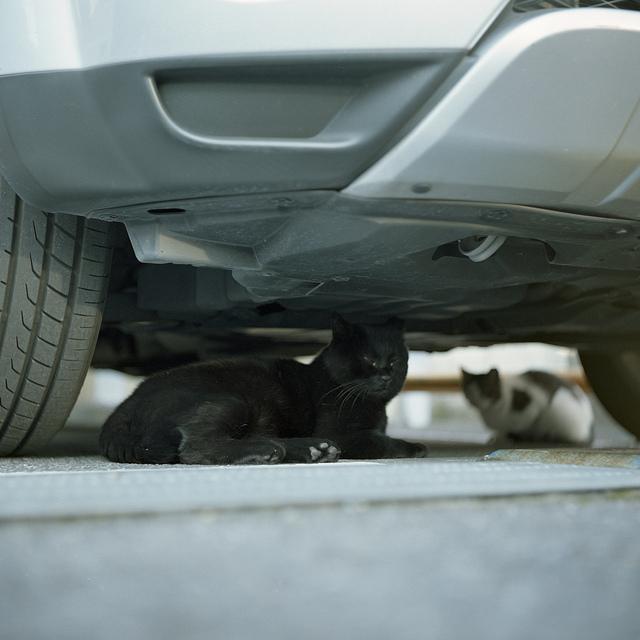How many cats are there?
Give a very brief answer. 2. How many cars are there?
Give a very brief answer. 1. 